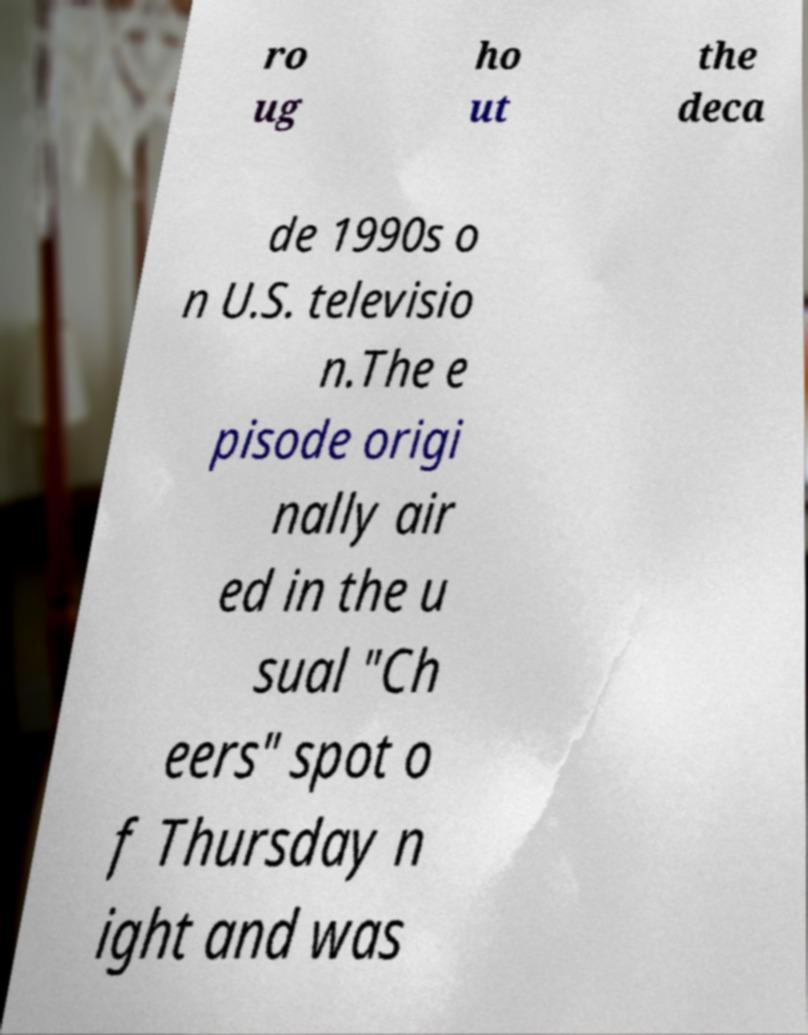Could you assist in decoding the text presented in this image and type it out clearly? ro ug ho ut the deca de 1990s o n U.S. televisio n.The e pisode origi nally air ed in the u sual "Ch eers" spot o f Thursday n ight and was 